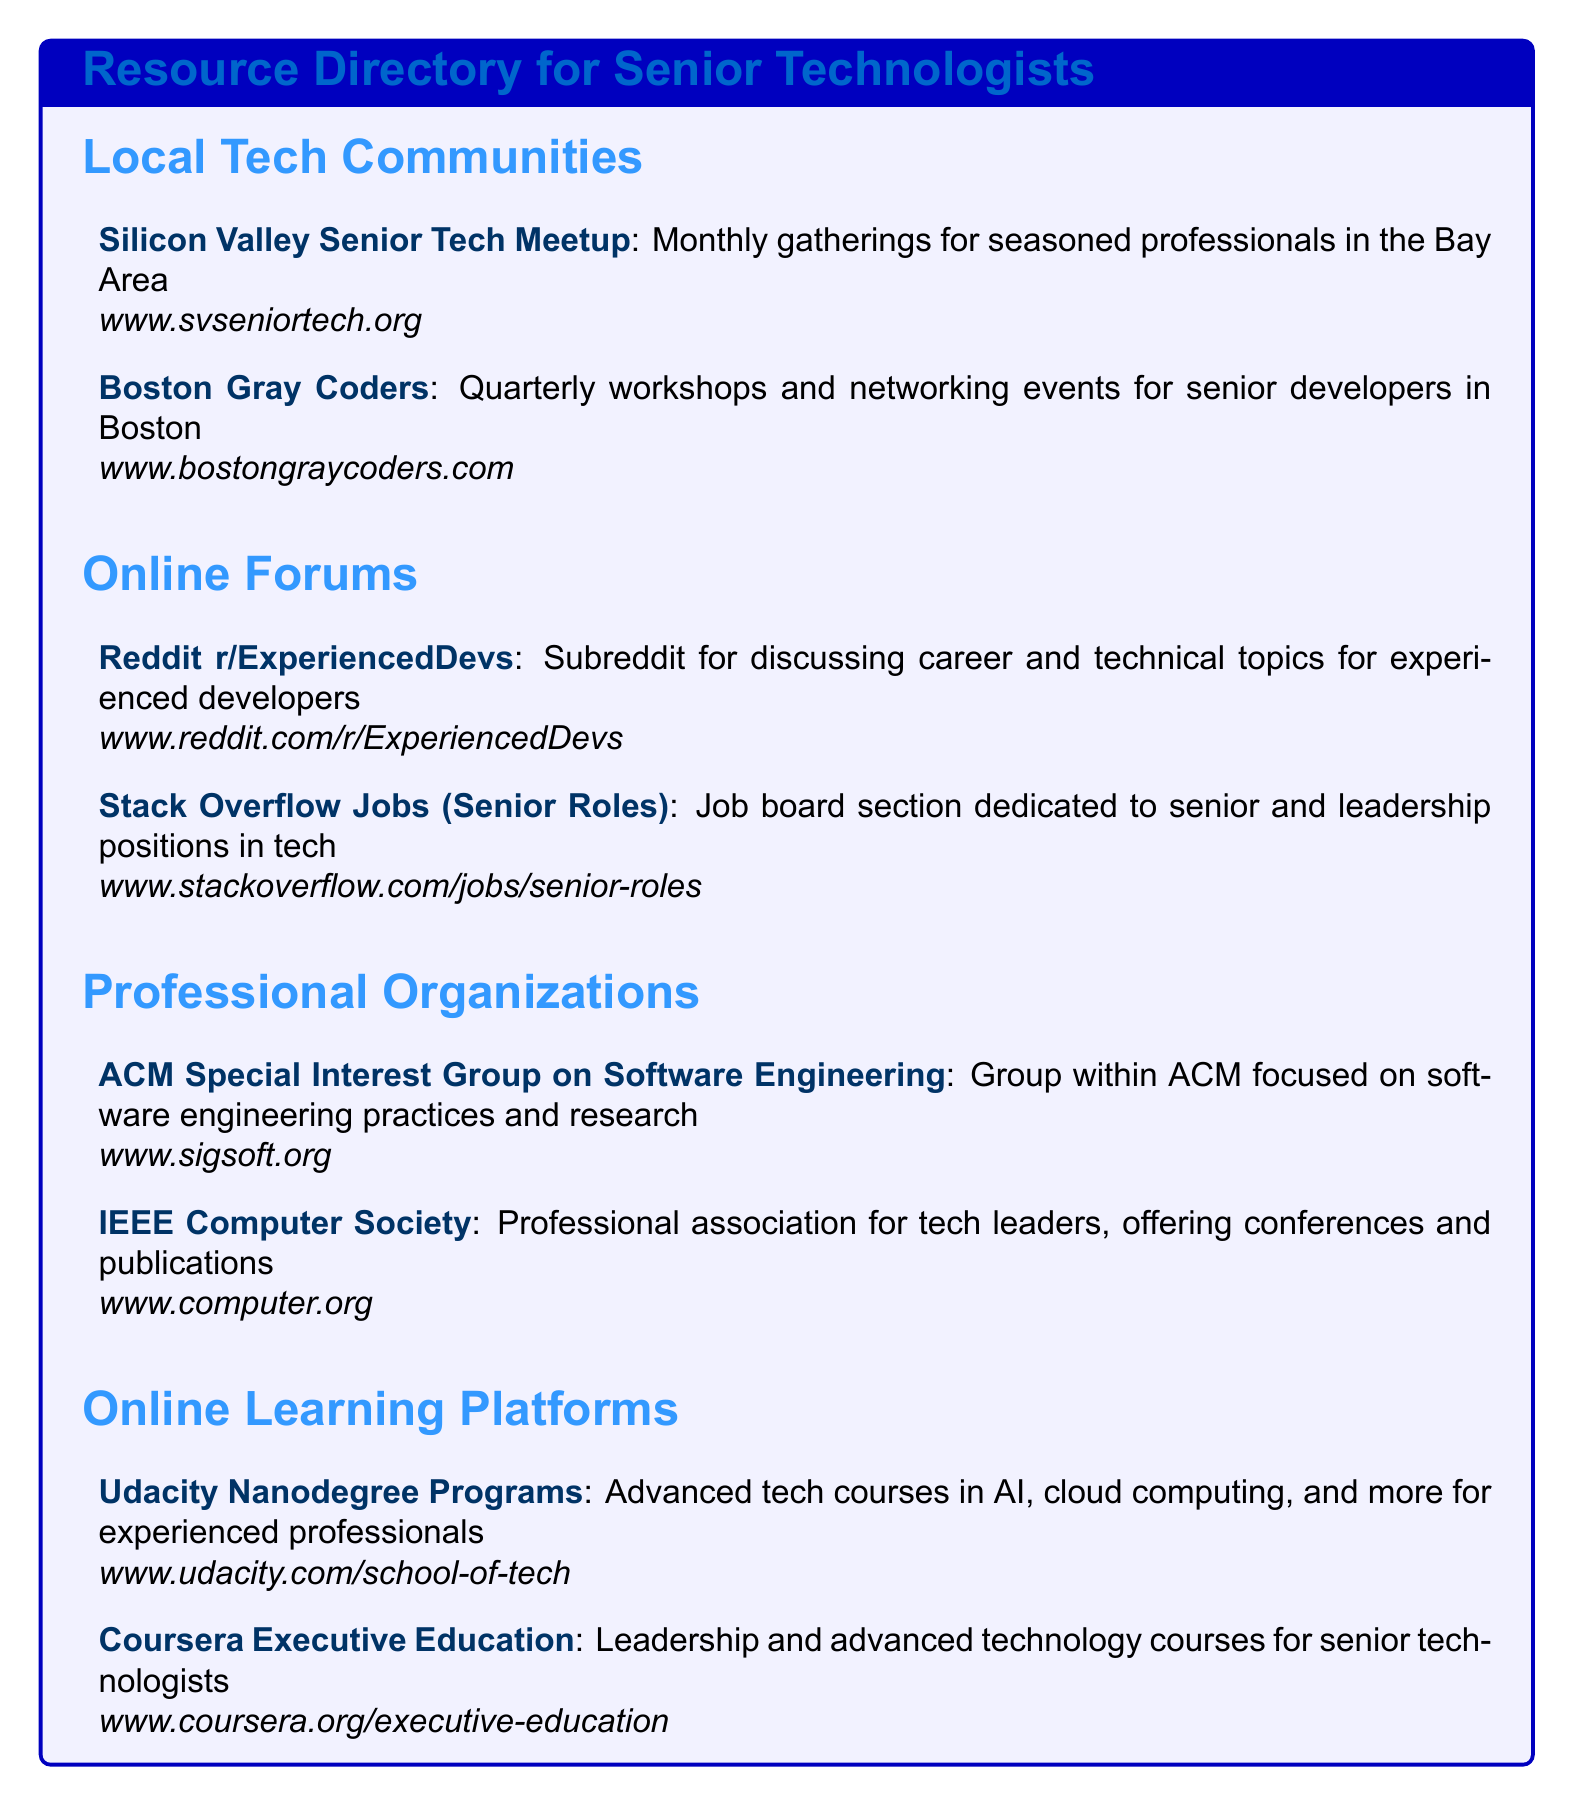What is the name of the local tech community in Boston? The relevant section lists the Boston Gray Coders as a local tech community for senior developers in Boston.
Answer: Boston Gray Coders How often do the Silicon Valley Senior Tech Meetup gatherings occur? According to the document, the gatherings are monthly events for seasoned professionals in the Bay Area.
Answer: Monthly What is the focus of the ACM Special Interest Group on Software Engineering? The document indicates that this group focuses on software engineering practices and research within the ACM organization.
Answer: Software engineering practices Which online learning platform offers leadership courses for senior technologists? The document lists Coursera Executive Education as a resource for leadership and advanced technology courses.
Answer: Coursera Executive Education What type of job positions are featured on the Stack Overflow Jobs section mentioned? The document specifies that this job board section is dedicated to senior and leadership positions in tech.
Answer: Senior roles How many local tech communities are mentioned in the document? By counting the listed local tech communities, there are two named in the document.
Answer: 2 What is the website for Boston Gray Coders? The document provides the official website as www.bostongraycoders.com.
Answer: www.bostongraycoders.com What is the title of the resource directory? The title of the resource directory is indicated prominently in the document’s header.
Answer: Resource Directory for Senior Technologists 